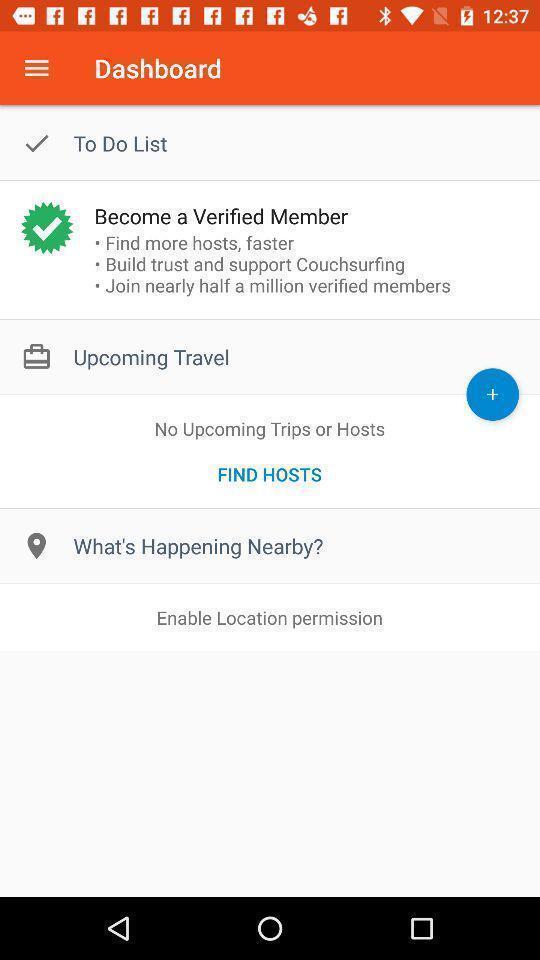Provide a textual representation of this image. Page showing variety of options like member. 